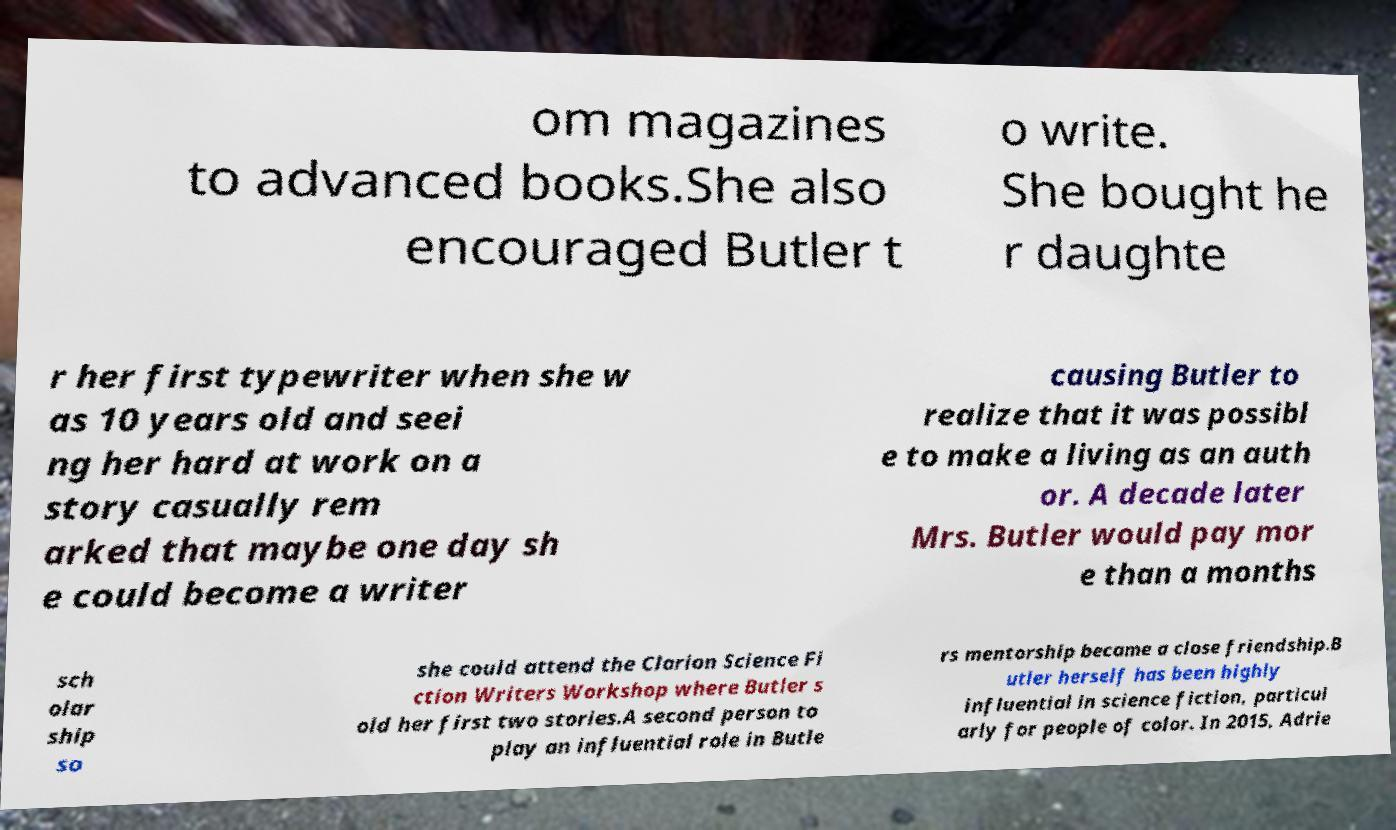For documentation purposes, I need the text within this image transcribed. Could you provide that? om magazines to advanced books.She also encouraged Butler t o write. She bought he r daughte r her first typewriter when she w as 10 years old and seei ng her hard at work on a story casually rem arked that maybe one day sh e could become a writer causing Butler to realize that it was possibl e to make a living as an auth or. A decade later Mrs. Butler would pay mor e than a months sch olar ship so she could attend the Clarion Science Fi ction Writers Workshop where Butler s old her first two stories.A second person to play an influential role in Butle rs mentorship became a close friendship.B utler herself has been highly influential in science fiction, particul arly for people of color. In 2015, Adrie 